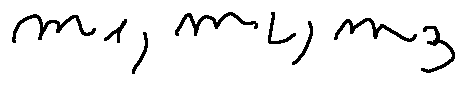Convert formula to latex. <formula><loc_0><loc_0><loc_500><loc_500>m _ { 1 } , m _ { 2 } , m _ { 3 }</formula> 